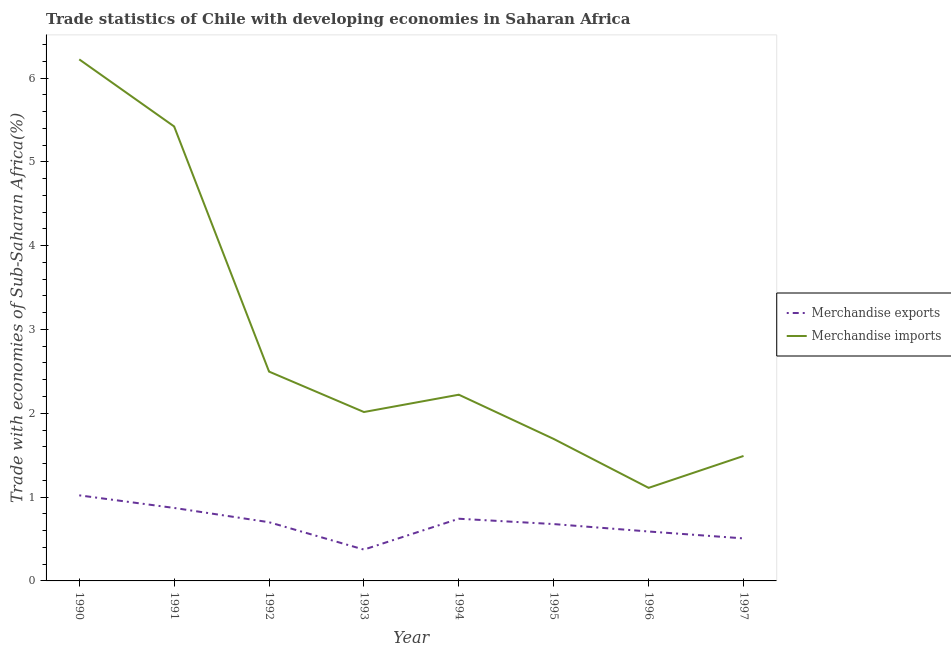Does the line corresponding to merchandise imports intersect with the line corresponding to merchandise exports?
Offer a very short reply. No. Is the number of lines equal to the number of legend labels?
Your response must be concise. Yes. What is the merchandise exports in 1995?
Provide a short and direct response. 0.68. Across all years, what is the maximum merchandise exports?
Make the answer very short. 1.02. Across all years, what is the minimum merchandise imports?
Your answer should be compact. 1.11. In which year was the merchandise exports maximum?
Your answer should be very brief. 1990. What is the total merchandise imports in the graph?
Ensure brevity in your answer.  22.67. What is the difference between the merchandise exports in 1993 and that in 1995?
Provide a succinct answer. -0.3. What is the difference between the merchandise exports in 1993 and the merchandise imports in 1994?
Make the answer very short. -1.85. What is the average merchandise exports per year?
Ensure brevity in your answer.  0.69. In the year 1993, what is the difference between the merchandise imports and merchandise exports?
Ensure brevity in your answer.  1.64. In how many years, is the merchandise imports greater than 4.2 %?
Provide a succinct answer. 2. What is the ratio of the merchandise exports in 1992 to that in 1995?
Your answer should be compact. 1.03. Is the merchandise exports in 1994 less than that in 1996?
Your response must be concise. No. Is the difference between the merchandise exports in 1991 and 1992 greater than the difference between the merchandise imports in 1991 and 1992?
Provide a short and direct response. No. What is the difference between the highest and the second highest merchandise exports?
Keep it short and to the point. 0.15. What is the difference between the highest and the lowest merchandise imports?
Keep it short and to the point. 5.11. In how many years, is the merchandise exports greater than the average merchandise exports taken over all years?
Ensure brevity in your answer.  4. Does the merchandise imports monotonically increase over the years?
Keep it short and to the point. No. Is the merchandise exports strictly greater than the merchandise imports over the years?
Offer a terse response. No. Is the merchandise imports strictly less than the merchandise exports over the years?
Make the answer very short. No. Are the values on the major ticks of Y-axis written in scientific E-notation?
Give a very brief answer. No. Does the graph contain any zero values?
Give a very brief answer. No. Does the graph contain grids?
Provide a short and direct response. No. Where does the legend appear in the graph?
Ensure brevity in your answer.  Center right. How many legend labels are there?
Provide a succinct answer. 2. What is the title of the graph?
Ensure brevity in your answer.  Trade statistics of Chile with developing economies in Saharan Africa. What is the label or title of the X-axis?
Offer a very short reply. Year. What is the label or title of the Y-axis?
Provide a short and direct response. Trade with economies of Sub-Saharan Africa(%). What is the Trade with economies of Sub-Saharan Africa(%) of Merchandise exports in 1990?
Your answer should be very brief. 1.02. What is the Trade with economies of Sub-Saharan Africa(%) of Merchandise imports in 1990?
Ensure brevity in your answer.  6.22. What is the Trade with economies of Sub-Saharan Africa(%) of Merchandise exports in 1991?
Provide a short and direct response. 0.87. What is the Trade with economies of Sub-Saharan Africa(%) of Merchandise imports in 1991?
Provide a short and direct response. 5.42. What is the Trade with economies of Sub-Saharan Africa(%) of Merchandise exports in 1992?
Offer a terse response. 0.7. What is the Trade with economies of Sub-Saharan Africa(%) in Merchandise imports in 1992?
Make the answer very short. 2.5. What is the Trade with economies of Sub-Saharan Africa(%) of Merchandise exports in 1993?
Provide a succinct answer. 0.37. What is the Trade with economies of Sub-Saharan Africa(%) of Merchandise imports in 1993?
Provide a short and direct response. 2.02. What is the Trade with economies of Sub-Saharan Africa(%) in Merchandise exports in 1994?
Your answer should be very brief. 0.74. What is the Trade with economies of Sub-Saharan Africa(%) of Merchandise imports in 1994?
Make the answer very short. 2.22. What is the Trade with economies of Sub-Saharan Africa(%) in Merchandise exports in 1995?
Give a very brief answer. 0.68. What is the Trade with economies of Sub-Saharan Africa(%) of Merchandise imports in 1995?
Your response must be concise. 1.69. What is the Trade with economies of Sub-Saharan Africa(%) of Merchandise exports in 1996?
Give a very brief answer. 0.59. What is the Trade with economies of Sub-Saharan Africa(%) of Merchandise imports in 1996?
Make the answer very short. 1.11. What is the Trade with economies of Sub-Saharan Africa(%) of Merchandise exports in 1997?
Ensure brevity in your answer.  0.51. What is the Trade with economies of Sub-Saharan Africa(%) of Merchandise imports in 1997?
Ensure brevity in your answer.  1.49. Across all years, what is the maximum Trade with economies of Sub-Saharan Africa(%) of Merchandise exports?
Your answer should be compact. 1.02. Across all years, what is the maximum Trade with economies of Sub-Saharan Africa(%) in Merchandise imports?
Your answer should be very brief. 6.22. Across all years, what is the minimum Trade with economies of Sub-Saharan Africa(%) of Merchandise exports?
Offer a very short reply. 0.37. Across all years, what is the minimum Trade with economies of Sub-Saharan Africa(%) in Merchandise imports?
Ensure brevity in your answer.  1.11. What is the total Trade with economies of Sub-Saharan Africa(%) in Merchandise exports in the graph?
Your answer should be very brief. 5.48. What is the total Trade with economies of Sub-Saharan Africa(%) of Merchandise imports in the graph?
Your answer should be compact. 22.67. What is the difference between the Trade with economies of Sub-Saharan Africa(%) of Merchandise exports in 1990 and that in 1991?
Offer a very short reply. 0.15. What is the difference between the Trade with economies of Sub-Saharan Africa(%) in Merchandise imports in 1990 and that in 1991?
Provide a short and direct response. 0.8. What is the difference between the Trade with economies of Sub-Saharan Africa(%) of Merchandise exports in 1990 and that in 1992?
Your response must be concise. 0.32. What is the difference between the Trade with economies of Sub-Saharan Africa(%) in Merchandise imports in 1990 and that in 1992?
Your response must be concise. 3.72. What is the difference between the Trade with economies of Sub-Saharan Africa(%) of Merchandise exports in 1990 and that in 1993?
Give a very brief answer. 0.65. What is the difference between the Trade with economies of Sub-Saharan Africa(%) of Merchandise imports in 1990 and that in 1993?
Keep it short and to the point. 4.21. What is the difference between the Trade with economies of Sub-Saharan Africa(%) in Merchandise exports in 1990 and that in 1994?
Offer a terse response. 0.28. What is the difference between the Trade with economies of Sub-Saharan Africa(%) in Merchandise imports in 1990 and that in 1994?
Keep it short and to the point. 4. What is the difference between the Trade with economies of Sub-Saharan Africa(%) in Merchandise exports in 1990 and that in 1995?
Offer a terse response. 0.34. What is the difference between the Trade with economies of Sub-Saharan Africa(%) in Merchandise imports in 1990 and that in 1995?
Your answer should be very brief. 4.53. What is the difference between the Trade with economies of Sub-Saharan Africa(%) in Merchandise exports in 1990 and that in 1996?
Provide a short and direct response. 0.43. What is the difference between the Trade with economies of Sub-Saharan Africa(%) of Merchandise imports in 1990 and that in 1996?
Provide a succinct answer. 5.11. What is the difference between the Trade with economies of Sub-Saharan Africa(%) in Merchandise exports in 1990 and that in 1997?
Your response must be concise. 0.51. What is the difference between the Trade with economies of Sub-Saharan Africa(%) of Merchandise imports in 1990 and that in 1997?
Ensure brevity in your answer.  4.73. What is the difference between the Trade with economies of Sub-Saharan Africa(%) in Merchandise exports in 1991 and that in 1992?
Offer a terse response. 0.17. What is the difference between the Trade with economies of Sub-Saharan Africa(%) of Merchandise imports in 1991 and that in 1992?
Your answer should be compact. 2.92. What is the difference between the Trade with economies of Sub-Saharan Africa(%) in Merchandise exports in 1991 and that in 1993?
Your response must be concise. 0.5. What is the difference between the Trade with economies of Sub-Saharan Africa(%) in Merchandise imports in 1991 and that in 1993?
Your answer should be compact. 3.41. What is the difference between the Trade with economies of Sub-Saharan Africa(%) of Merchandise exports in 1991 and that in 1994?
Ensure brevity in your answer.  0.13. What is the difference between the Trade with economies of Sub-Saharan Africa(%) in Merchandise imports in 1991 and that in 1994?
Your answer should be very brief. 3.2. What is the difference between the Trade with economies of Sub-Saharan Africa(%) of Merchandise exports in 1991 and that in 1995?
Give a very brief answer. 0.19. What is the difference between the Trade with economies of Sub-Saharan Africa(%) in Merchandise imports in 1991 and that in 1995?
Your answer should be very brief. 3.73. What is the difference between the Trade with economies of Sub-Saharan Africa(%) of Merchandise exports in 1991 and that in 1996?
Your answer should be compact. 0.28. What is the difference between the Trade with economies of Sub-Saharan Africa(%) in Merchandise imports in 1991 and that in 1996?
Provide a succinct answer. 4.31. What is the difference between the Trade with economies of Sub-Saharan Africa(%) of Merchandise exports in 1991 and that in 1997?
Your answer should be very brief. 0.36. What is the difference between the Trade with economies of Sub-Saharan Africa(%) of Merchandise imports in 1991 and that in 1997?
Make the answer very short. 3.93. What is the difference between the Trade with economies of Sub-Saharan Africa(%) of Merchandise exports in 1992 and that in 1993?
Make the answer very short. 0.33. What is the difference between the Trade with economies of Sub-Saharan Africa(%) in Merchandise imports in 1992 and that in 1993?
Offer a terse response. 0.48. What is the difference between the Trade with economies of Sub-Saharan Africa(%) of Merchandise exports in 1992 and that in 1994?
Give a very brief answer. -0.04. What is the difference between the Trade with economies of Sub-Saharan Africa(%) of Merchandise imports in 1992 and that in 1994?
Keep it short and to the point. 0.28. What is the difference between the Trade with economies of Sub-Saharan Africa(%) in Merchandise exports in 1992 and that in 1995?
Make the answer very short. 0.02. What is the difference between the Trade with economies of Sub-Saharan Africa(%) of Merchandise imports in 1992 and that in 1995?
Provide a succinct answer. 0.8. What is the difference between the Trade with economies of Sub-Saharan Africa(%) in Merchandise exports in 1992 and that in 1996?
Your answer should be compact. 0.11. What is the difference between the Trade with economies of Sub-Saharan Africa(%) in Merchandise imports in 1992 and that in 1996?
Your response must be concise. 1.39. What is the difference between the Trade with economies of Sub-Saharan Africa(%) in Merchandise exports in 1992 and that in 1997?
Give a very brief answer. 0.19. What is the difference between the Trade with economies of Sub-Saharan Africa(%) in Merchandise imports in 1992 and that in 1997?
Provide a short and direct response. 1.01. What is the difference between the Trade with economies of Sub-Saharan Africa(%) of Merchandise exports in 1993 and that in 1994?
Your answer should be compact. -0.37. What is the difference between the Trade with economies of Sub-Saharan Africa(%) in Merchandise imports in 1993 and that in 1994?
Your answer should be very brief. -0.21. What is the difference between the Trade with economies of Sub-Saharan Africa(%) of Merchandise exports in 1993 and that in 1995?
Keep it short and to the point. -0.3. What is the difference between the Trade with economies of Sub-Saharan Africa(%) of Merchandise imports in 1993 and that in 1995?
Your response must be concise. 0.32. What is the difference between the Trade with economies of Sub-Saharan Africa(%) of Merchandise exports in 1993 and that in 1996?
Ensure brevity in your answer.  -0.22. What is the difference between the Trade with economies of Sub-Saharan Africa(%) in Merchandise imports in 1993 and that in 1996?
Your response must be concise. 0.9. What is the difference between the Trade with economies of Sub-Saharan Africa(%) in Merchandise exports in 1993 and that in 1997?
Provide a succinct answer. -0.13. What is the difference between the Trade with economies of Sub-Saharan Africa(%) of Merchandise imports in 1993 and that in 1997?
Your answer should be very brief. 0.52. What is the difference between the Trade with economies of Sub-Saharan Africa(%) in Merchandise exports in 1994 and that in 1995?
Provide a short and direct response. 0.06. What is the difference between the Trade with economies of Sub-Saharan Africa(%) of Merchandise imports in 1994 and that in 1995?
Ensure brevity in your answer.  0.53. What is the difference between the Trade with economies of Sub-Saharan Africa(%) in Merchandise exports in 1994 and that in 1996?
Your answer should be compact. 0.15. What is the difference between the Trade with economies of Sub-Saharan Africa(%) of Merchandise imports in 1994 and that in 1996?
Ensure brevity in your answer.  1.11. What is the difference between the Trade with economies of Sub-Saharan Africa(%) in Merchandise exports in 1994 and that in 1997?
Ensure brevity in your answer.  0.23. What is the difference between the Trade with economies of Sub-Saharan Africa(%) in Merchandise imports in 1994 and that in 1997?
Give a very brief answer. 0.73. What is the difference between the Trade with economies of Sub-Saharan Africa(%) of Merchandise exports in 1995 and that in 1996?
Your answer should be compact. 0.09. What is the difference between the Trade with economies of Sub-Saharan Africa(%) of Merchandise imports in 1995 and that in 1996?
Give a very brief answer. 0.58. What is the difference between the Trade with economies of Sub-Saharan Africa(%) of Merchandise exports in 1995 and that in 1997?
Ensure brevity in your answer.  0.17. What is the difference between the Trade with economies of Sub-Saharan Africa(%) of Merchandise imports in 1995 and that in 1997?
Provide a short and direct response. 0.2. What is the difference between the Trade with economies of Sub-Saharan Africa(%) in Merchandise exports in 1996 and that in 1997?
Provide a succinct answer. 0.08. What is the difference between the Trade with economies of Sub-Saharan Africa(%) of Merchandise imports in 1996 and that in 1997?
Offer a terse response. -0.38. What is the difference between the Trade with economies of Sub-Saharan Africa(%) of Merchandise exports in 1990 and the Trade with economies of Sub-Saharan Africa(%) of Merchandise imports in 1991?
Offer a terse response. -4.4. What is the difference between the Trade with economies of Sub-Saharan Africa(%) of Merchandise exports in 1990 and the Trade with economies of Sub-Saharan Africa(%) of Merchandise imports in 1992?
Your response must be concise. -1.48. What is the difference between the Trade with economies of Sub-Saharan Africa(%) in Merchandise exports in 1990 and the Trade with economies of Sub-Saharan Africa(%) in Merchandise imports in 1993?
Give a very brief answer. -0.99. What is the difference between the Trade with economies of Sub-Saharan Africa(%) in Merchandise exports in 1990 and the Trade with economies of Sub-Saharan Africa(%) in Merchandise imports in 1994?
Provide a short and direct response. -1.2. What is the difference between the Trade with economies of Sub-Saharan Africa(%) of Merchandise exports in 1990 and the Trade with economies of Sub-Saharan Africa(%) of Merchandise imports in 1995?
Offer a terse response. -0.67. What is the difference between the Trade with economies of Sub-Saharan Africa(%) of Merchandise exports in 1990 and the Trade with economies of Sub-Saharan Africa(%) of Merchandise imports in 1996?
Ensure brevity in your answer.  -0.09. What is the difference between the Trade with economies of Sub-Saharan Africa(%) in Merchandise exports in 1990 and the Trade with economies of Sub-Saharan Africa(%) in Merchandise imports in 1997?
Your answer should be very brief. -0.47. What is the difference between the Trade with economies of Sub-Saharan Africa(%) of Merchandise exports in 1991 and the Trade with economies of Sub-Saharan Africa(%) of Merchandise imports in 1992?
Offer a very short reply. -1.63. What is the difference between the Trade with economies of Sub-Saharan Africa(%) of Merchandise exports in 1991 and the Trade with economies of Sub-Saharan Africa(%) of Merchandise imports in 1993?
Offer a terse response. -1.14. What is the difference between the Trade with economies of Sub-Saharan Africa(%) of Merchandise exports in 1991 and the Trade with economies of Sub-Saharan Africa(%) of Merchandise imports in 1994?
Ensure brevity in your answer.  -1.35. What is the difference between the Trade with economies of Sub-Saharan Africa(%) of Merchandise exports in 1991 and the Trade with economies of Sub-Saharan Africa(%) of Merchandise imports in 1995?
Offer a very short reply. -0.82. What is the difference between the Trade with economies of Sub-Saharan Africa(%) in Merchandise exports in 1991 and the Trade with economies of Sub-Saharan Africa(%) in Merchandise imports in 1996?
Keep it short and to the point. -0.24. What is the difference between the Trade with economies of Sub-Saharan Africa(%) in Merchandise exports in 1991 and the Trade with economies of Sub-Saharan Africa(%) in Merchandise imports in 1997?
Ensure brevity in your answer.  -0.62. What is the difference between the Trade with economies of Sub-Saharan Africa(%) in Merchandise exports in 1992 and the Trade with economies of Sub-Saharan Africa(%) in Merchandise imports in 1993?
Make the answer very short. -1.31. What is the difference between the Trade with economies of Sub-Saharan Africa(%) in Merchandise exports in 1992 and the Trade with economies of Sub-Saharan Africa(%) in Merchandise imports in 1994?
Make the answer very short. -1.52. What is the difference between the Trade with economies of Sub-Saharan Africa(%) of Merchandise exports in 1992 and the Trade with economies of Sub-Saharan Africa(%) of Merchandise imports in 1995?
Provide a succinct answer. -0.99. What is the difference between the Trade with economies of Sub-Saharan Africa(%) in Merchandise exports in 1992 and the Trade with economies of Sub-Saharan Africa(%) in Merchandise imports in 1996?
Offer a terse response. -0.41. What is the difference between the Trade with economies of Sub-Saharan Africa(%) in Merchandise exports in 1992 and the Trade with economies of Sub-Saharan Africa(%) in Merchandise imports in 1997?
Keep it short and to the point. -0.79. What is the difference between the Trade with economies of Sub-Saharan Africa(%) of Merchandise exports in 1993 and the Trade with economies of Sub-Saharan Africa(%) of Merchandise imports in 1994?
Make the answer very short. -1.85. What is the difference between the Trade with economies of Sub-Saharan Africa(%) of Merchandise exports in 1993 and the Trade with economies of Sub-Saharan Africa(%) of Merchandise imports in 1995?
Provide a short and direct response. -1.32. What is the difference between the Trade with economies of Sub-Saharan Africa(%) in Merchandise exports in 1993 and the Trade with economies of Sub-Saharan Africa(%) in Merchandise imports in 1996?
Provide a succinct answer. -0.74. What is the difference between the Trade with economies of Sub-Saharan Africa(%) of Merchandise exports in 1993 and the Trade with economies of Sub-Saharan Africa(%) of Merchandise imports in 1997?
Your answer should be compact. -1.12. What is the difference between the Trade with economies of Sub-Saharan Africa(%) in Merchandise exports in 1994 and the Trade with economies of Sub-Saharan Africa(%) in Merchandise imports in 1995?
Give a very brief answer. -0.95. What is the difference between the Trade with economies of Sub-Saharan Africa(%) in Merchandise exports in 1994 and the Trade with economies of Sub-Saharan Africa(%) in Merchandise imports in 1996?
Provide a succinct answer. -0.37. What is the difference between the Trade with economies of Sub-Saharan Africa(%) of Merchandise exports in 1994 and the Trade with economies of Sub-Saharan Africa(%) of Merchandise imports in 1997?
Provide a short and direct response. -0.75. What is the difference between the Trade with economies of Sub-Saharan Africa(%) in Merchandise exports in 1995 and the Trade with economies of Sub-Saharan Africa(%) in Merchandise imports in 1996?
Offer a very short reply. -0.43. What is the difference between the Trade with economies of Sub-Saharan Africa(%) of Merchandise exports in 1995 and the Trade with economies of Sub-Saharan Africa(%) of Merchandise imports in 1997?
Make the answer very short. -0.81. What is the difference between the Trade with economies of Sub-Saharan Africa(%) of Merchandise exports in 1996 and the Trade with economies of Sub-Saharan Africa(%) of Merchandise imports in 1997?
Provide a succinct answer. -0.9. What is the average Trade with economies of Sub-Saharan Africa(%) of Merchandise exports per year?
Your answer should be very brief. 0.69. What is the average Trade with economies of Sub-Saharan Africa(%) of Merchandise imports per year?
Provide a short and direct response. 2.83. In the year 1990, what is the difference between the Trade with economies of Sub-Saharan Africa(%) in Merchandise exports and Trade with economies of Sub-Saharan Africa(%) in Merchandise imports?
Provide a succinct answer. -5.2. In the year 1991, what is the difference between the Trade with economies of Sub-Saharan Africa(%) of Merchandise exports and Trade with economies of Sub-Saharan Africa(%) of Merchandise imports?
Give a very brief answer. -4.55. In the year 1992, what is the difference between the Trade with economies of Sub-Saharan Africa(%) of Merchandise exports and Trade with economies of Sub-Saharan Africa(%) of Merchandise imports?
Keep it short and to the point. -1.8. In the year 1993, what is the difference between the Trade with economies of Sub-Saharan Africa(%) of Merchandise exports and Trade with economies of Sub-Saharan Africa(%) of Merchandise imports?
Offer a terse response. -1.64. In the year 1994, what is the difference between the Trade with economies of Sub-Saharan Africa(%) in Merchandise exports and Trade with economies of Sub-Saharan Africa(%) in Merchandise imports?
Your answer should be very brief. -1.48. In the year 1995, what is the difference between the Trade with economies of Sub-Saharan Africa(%) in Merchandise exports and Trade with economies of Sub-Saharan Africa(%) in Merchandise imports?
Offer a terse response. -1.02. In the year 1996, what is the difference between the Trade with economies of Sub-Saharan Africa(%) in Merchandise exports and Trade with economies of Sub-Saharan Africa(%) in Merchandise imports?
Your answer should be very brief. -0.52. In the year 1997, what is the difference between the Trade with economies of Sub-Saharan Africa(%) in Merchandise exports and Trade with economies of Sub-Saharan Africa(%) in Merchandise imports?
Your response must be concise. -0.98. What is the ratio of the Trade with economies of Sub-Saharan Africa(%) in Merchandise exports in 1990 to that in 1991?
Your answer should be very brief. 1.17. What is the ratio of the Trade with economies of Sub-Saharan Africa(%) of Merchandise imports in 1990 to that in 1991?
Your answer should be very brief. 1.15. What is the ratio of the Trade with economies of Sub-Saharan Africa(%) of Merchandise exports in 1990 to that in 1992?
Provide a succinct answer. 1.46. What is the ratio of the Trade with economies of Sub-Saharan Africa(%) of Merchandise imports in 1990 to that in 1992?
Give a very brief answer. 2.49. What is the ratio of the Trade with economies of Sub-Saharan Africa(%) of Merchandise exports in 1990 to that in 1993?
Your answer should be compact. 2.73. What is the ratio of the Trade with economies of Sub-Saharan Africa(%) of Merchandise imports in 1990 to that in 1993?
Keep it short and to the point. 3.09. What is the ratio of the Trade with economies of Sub-Saharan Africa(%) of Merchandise exports in 1990 to that in 1994?
Your response must be concise. 1.38. What is the ratio of the Trade with economies of Sub-Saharan Africa(%) in Merchandise imports in 1990 to that in 1994?
Your response must be concise. 2.8. What is the ratio of the Trade with economies of Sub-Saharan Africa(%) of Merchandise exports in 1990 to that in 1995?
Keep it short and to the point. 1.51. What is the ratio of the Trade with economies of Sub-Saharan Africa(%) in Merchandise imports in 1990 to that in 1995?
Provide a short and direct response. 3.67. What is the ratio of the Trade with economies of Sub-Saharan Africa(%) of Merchandise exports in 1990 to that in 1996?
Offer a terse response. 1.73. What is the ratio of the Trade with economies of Sub-Saharan Africa(%) in Merchandise imports in 1990 to that in 1996?
Your answer should be compact. 5.6. What is the ratio of the Trade with economies of Sub-Saharan Africa(%) in Merchandise exports in 1990 to that in 1997?
Your answer should be compact. 2.01. What is the ratio of the Trade with economies of Sub-Saharan Africa(%) in Merchandise imports in 1990 to that in 1997?
Offer a terse response. 4.17. What is the ratio of the Trade with economies of Sub-Saharan Africa(%) in Merchandise exports in 1991 to that in 1992?
Give a very brief answer. 1.24. What is the ratio of the Trade with economies of Sub-Saharan Africa(%) in Merchandise imports in 1991 to that in 1992?
Provide a short and direct response. 2.17. What is the ratio of the Trade with economies of Sub-Saharan Africa(%) in Merchandise exports in 1991 to that in 1993?
Offer a very short reply. 2.33. What is the ratio of the Trade with economies of Sub-Saharan Africa(%) of Merchandise imports in 1991 to that in 1993?
Your answer should be very brief. 2.69. What is the ratio of the Trade with economies of Sub-Saharan Africa(%) in Merchandise exports in 1991 to that in 1994?
Your answer should be compact. 1.17. What is the ratio of the Trade with economies of Sub-Saharan Africa(%) in Merchandise imports in 1991 to that in 1994?
Your answer should be very brief. 2.44. What is the ratio of the Trade with economies of Sub-Saharan Africa(%) in Merchandise exports in 1991 to that in 1995?
Give a very brief answer. 1.28. What is the ratio of the Trade with economies of Sub-Saharan Africa(%) of Merchandise imports in 1991 to that in 1995?
Your answer should be very brief. 3.2. What is the ratio of the Trade with economies of Sub-Saharan Africa(%) in Merchandise exports in 1991 to that in 1996?
Your answer should be compact. 1.48. What is the ratio of the Trade with economies of Sub-Saharan Africa(%) of Merchandise imports in 1991 to that in 1996?
Your response must be concise. 4.88. What is the ratio of the Trade with economies of Sub-Saharan Africa(%) of Merchandise exports in 1991 to that in 1997?
Ensure brevity in your answer.  1.72. What is the ratio of the Trade with economies of Sub-Saharan Africa(%) in Merchandise imports in 1991 to that in 1997?
Give a very brief answer. 3.64. What is the ratio of the Trade with economies of Sub-Saharan Africa(%) in Merchandise exports in 1992 to that in 1993?
Make the answer very short. 1.87. What is the ratio of the Trade with economies of Sub-Saharan Africa(%) in Merchandise imports in 1992 to that in 1993?
Your answer should be compact. 1.24. What is the ratio of the Trade with economies of Sub-Saharan Africa(%) in Merchandise exports in 1992 to that in 1994?
Ensure brevity in your answer.  0.94. What is the ratio of the Trade with economies of Sub-Saharan Africa(%) of Merchandise imports in 1992 to that in 1994?
Provide a succinct answer. 1.12. What is the ratio of the Trade with economies of Sub-Saharan Africa(%) in Merchandise exports in 1992 to that in 1995?
Provide a succinct answer. 1.03. What is the ratio of the Trade with economies of Sub-Saharan Africa(%) in Merchandise imports in 1992 to that in 1995?
Make the answer very short. 1.47. What is the ratio of the Trade with economies of Sub-Saharan Africa(%) in Merchandise exports in 1992 to that in 1996?
Provide a succinct answer. 1.19. What is the ratio of the Trade with economies of Sub-Saharan Africa(%) in Merchandise imports in 1992 to that in 1996?
Offer a terse response. 2.25. What is the ratio of the Trade with economies of Sub-Saharan Africa(%) in Merchandise exports in 1992 to that in 1997?
Provide a succinct answer. 1.38. What is the ratio of the Trade with economies of Sub-Saharan Africa(%) in Merchandise imports in 1992 to that in 1997?
Your answer should be compact. 1.68. What is the ratio of the Trade with economies of Sub-Saharan Africa(%) of Merchandise exports in 1993 to that in 1994?
Provide a succinct answer. 0.5. What is the ratio of the Trade with economies of Sub-Saharan Africa(%) in Merchandise imports in 1993 to that in 1994?
Your answer should be very brief. 0.91. What is the ratio of the Trade with economies of Sub-Saharan Africa(%) in Merchandise exports in 1993 to that in 1995?
Offer a very short reply. 0.55. What is the ratio of the Trade with economies of Sub-Saharan Africa(%) of Merchandise imports in 1993 to that in 1995?
Ensure brevity in your answer.  1.19. What is the ratio of the Trade with economies of Sub-Saharan Africa(%) in Merchandise exports in 1993 to that in 1996?
Provide a succinct answer. 0.63. What is the ratio of the Trade with economies of Sub-Saharan Africa(%) in Merchandise imports in 1993 to that in 1996?
Provide a short and direct response. 1.81. What is the ratio of the Trade with economies of Sub-Saharan Africa(%) of Merchandise exports in 1993 to that in 1997?
Offer a very short reply. 0.74. What is the ratio of the Trade with economies of Sub-Saharan Africa(%) of Merchandise imports in 1993 to that in 1997?
Your response must be concise. 1.35. What is the ratio of the Trade with economies of Sub-Saharan Africa(%) of Merchandise exports in 1994 to that in 1995?
Give a very brief answer. 1.09. What is the ratio of the Trade with economies of Sub-Saharan Africa(%) of Merchandise imports in 1994 to that in 1995?
Keep it short and to the point. 1.31. What is the ratio of the Trade with economies of Sub-Saharan Africa(%) in Merchandise exports in 1994 to that in 1996?
Keep it short and to the point. 1.26. What is the ratio of the Trade with economies of Sub-Saharan Africa(%) in Merchandise imports in 1994 to that in 1996?
Give a very brief answer. 2. What is the ratio of the Trade with economies of Sub-Saharan Africa(%) of Merchandise exports in 1994 to that in 1997?
Your answer should be very brief. 1.46. What is the ratio of the Trade with economies of Sub-Saharan Africa(%) of Merchandise imports in 1994 to that in 1997?
Your response must be concise. 1.49. What is the ratio of the Trade with economies of Sub-Saharan Africa(%) of Merchandise exports in 1995 to that in 1996?
Offer a very short reply. 1.15. What is the ratio of the Trade with economies of Sub-Saharan Africa(%) of Merchandise imports in 1995 to that in 1996?
Your answer should be very brief. 1.53. What is the ratio of the Trade with economies of Sub-Saharan Africa(%) of Merchandise exports in 1995 to that in 1997?
Provide a short and direct response. 1.34. What is the ratio of the Trade with economies of Sub-Saharan Africa(%) of Merchandise imports in 1995 to that in 1997?
Provide a succinct answer. 1.14. What is the ratio of the Trade with economies of Sub-Saharan Africa(%) in Merchandise exports in 1996 to that in 1997?
Provide a succinct answer. 1.16. What is the ratio of the Trade with economies of Sub-Saharan Africa(%) of Merchandise imports in 1996 to that in 1997?
Make the answer very short. 0.74. What is the difference between the highest and the second highest Trade with economies of Sub-Saharan Africa(%) in Merchandise exports?
Ensure brevity in your answer.  0.15. What is the difference between the highest and the second highest Trade with economies of Sub-Saharan Africa(%) in Merchandise imports?
Your answer should be compact. 0.8. What is the difference between the highest and the lowest Trade with economies of Sub-Saharan Africa(%) in Merchandise exports?
Give a very brief answer. 0.65. What is the difference between the highest and the lowest Trade with economies of Sub-Saharan Africa(%) of Merchandise imports?
Your answer should be very brief. 5.11. 